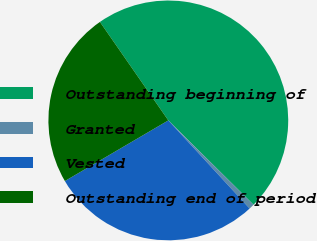Convert chart to OTSL. <chart><loc_0><loc_0><loc_500><loc_500><pie_chart><fcel>Outstanding beginning of<fcel>Granted<fcel>Vested<fcel>Outstanding end of period<nl><fcel>47.08%<fcel>0.72%<fcel>28.42%<fcel>23.78%<nl></chart> 